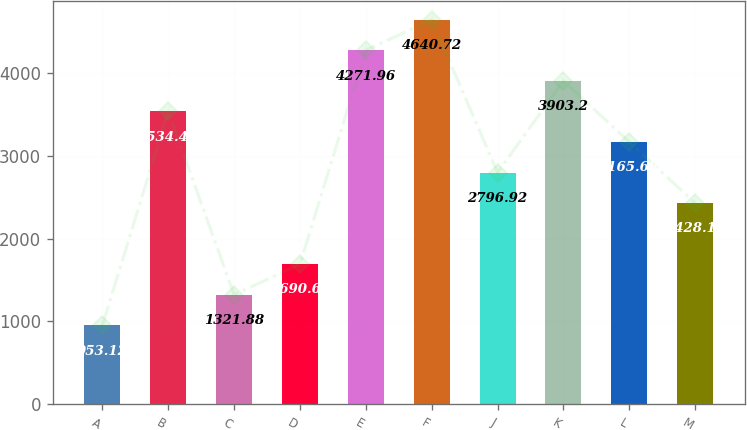<chart> <loc_0><loc_0><loc_500><loc_500><bar_chart><fcel>A<fcel>B<fcel>C<fcel>D<fcel>E<fcel>F<fcel>J<fcel>K<fcel>L<fcel>M<nl><fcel>953.12<fcel>3534.44<fcel>1321.88<fcel>1690.64<fcel>4271.96<fcel>4640.72<fcel>2796.92<fcel>3903.2<fcel>3165.68<fcel>2428.16<nl></chart> 